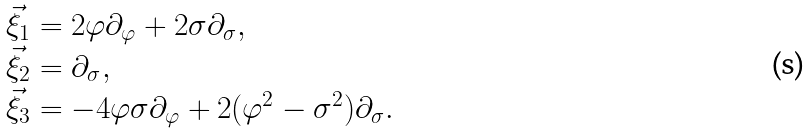Convert formula to latex. <formula><loc_0><loc_0><loc_500><loc_500>\begin{array} { l l } \vec { \xi } _ { 1 } = 2 \varphi { \partial } _ { \varphi } + 2 \sigma { \partial } _ { \sigma } , \\ \vec { \xi } _ { 2 } = { \partial } _ { \sigma } , \\ \vec { \xi } _ { 3 } = - 4 \varphi \sigma { \partial } _ { \varphi } + 2 ( \varphi ^ { 2 } - { \sigma } ^ { 2 } ) { \partial } _ { \sigma } . \end{array}</formula> 